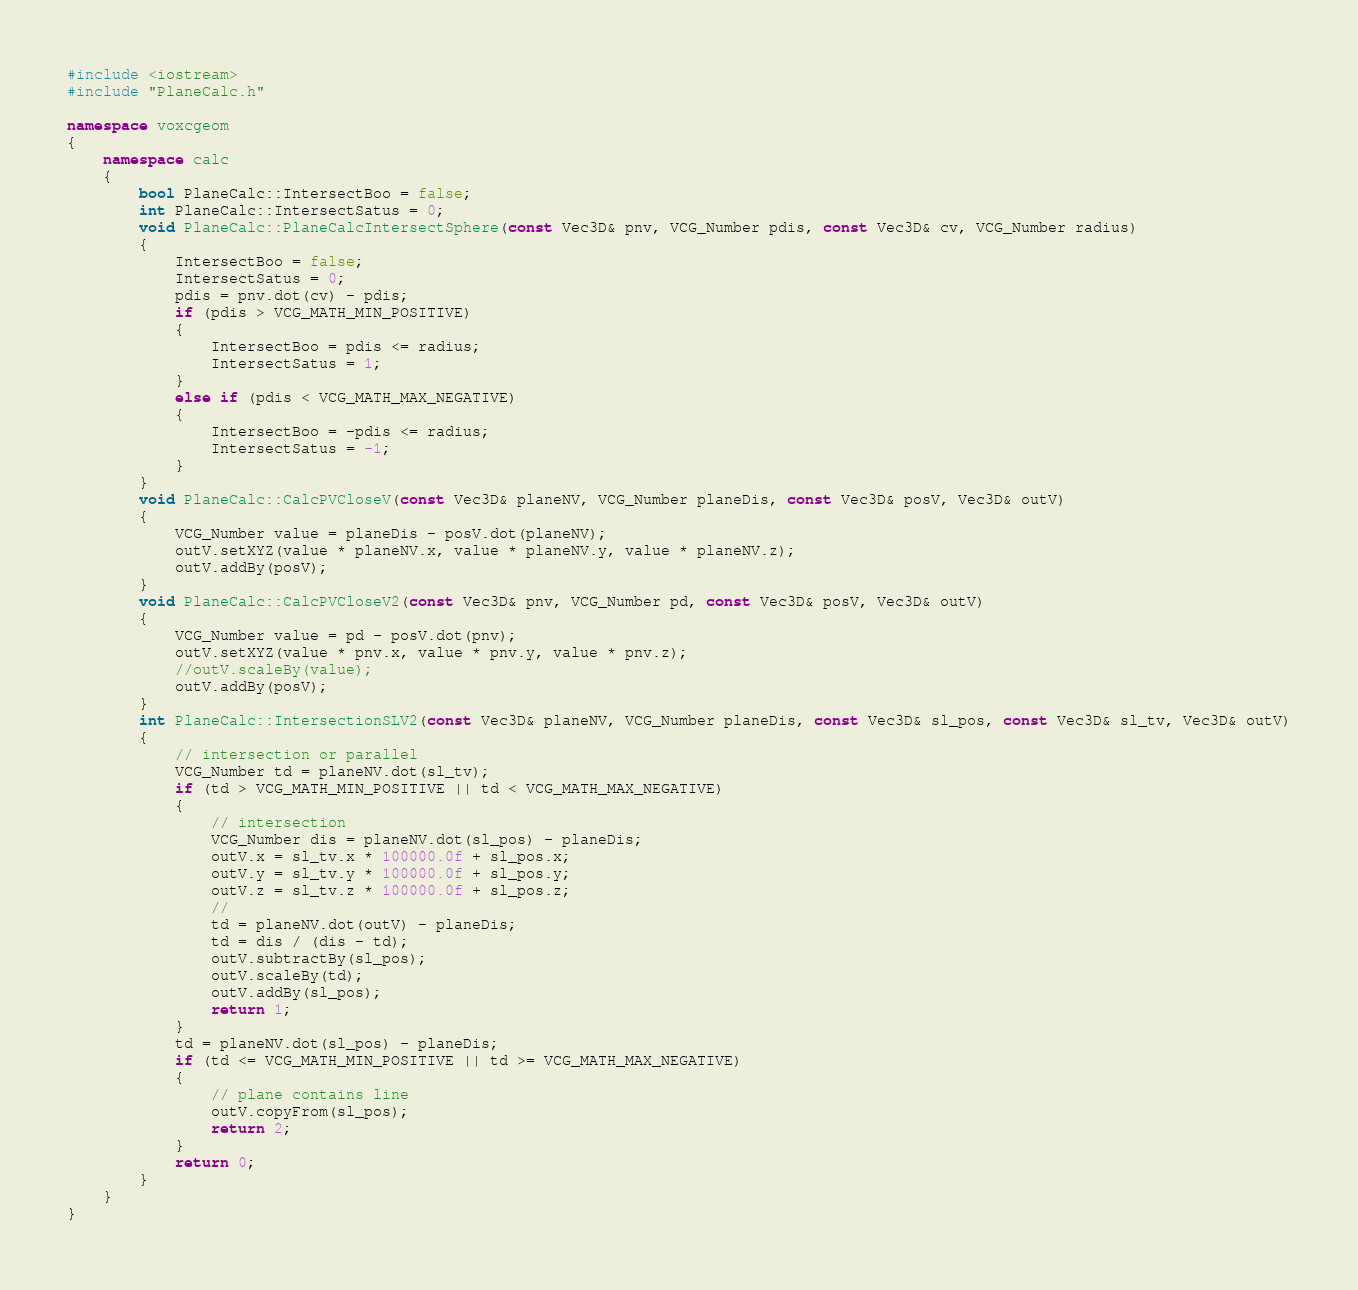Convert code to text. <code><loc_0><loc_0><loc_500><loc_500><_C++_>
#include <iostream>
#include "PlaneCalc.h"

namespace voxcgeom
{
	namespace calc
	{
		bool PlaneCalc::IntersectBoo = false;
		int PlaneCalc::IntersectSatus = 0;
		void PlaneCalc::PlaneCalcIntersectSphere(const Vec3D& pnv, VCG_Number pdis, const Vec3D& cv, VCG_Number radius)
		{
			IntersectBoo = false;
			IntersectSatus = 0;
			pdis = pnv.dot(cv) - pdis;
			if (pdis > VCG_MATH_MIN_POSITIVE)
			{
				IntersectBoo = pdis <= radius;
				IntersectSatus = 1;
			}
			else if (pdis < VCG_MATH_MAX_NEGATIVE)
			{
				IntersectBoo = -pdis <= radius;
				IntersectSatus = -1;
			}
		}
		void PlaneCalc::CalcPVCloseV(const Vec3D& planeNV, VCG_Number planeDis, const Vec3D& posV, Vec3D& outV)
		{
			VCG_Number value = planeDis - posV.dot(planeNV);
			outV.setXYZ(value * planeNV.x, value * planeNV.y, value * planeNV.z);
			outV.addBy(posV);
		}
		void PlaneCalc::CalcPVCloseV2(const Vec3D& pnv, VCG_Number pd, const Vec3D& posV, Vec3D& outV)
		{
			VCG_Number value = pd - posV.dot(pnv);
			outV.setXYZ(value * pnv.x, value * pnv.y, value * pnv.z);
			//outV.scaleBy(value);
			outV.addBy(posV);
		}
		int PlaneCalc::IntersectionSLV2(const Vec3D& planeNV, VCG_Number planeDis, const Vec3D& sl_pos, const Vec3D& sl_tv, Vec3D& outV)
		{
			// intersection or parallel
			VCG_Number td = planeNV.dot(sl_tv);
			if (td > VCG_MATH_MIN_POSITIVE || td < VCG_MATH_MAX_NEGATIVE)
			{
				// intersection
				VCG_Number dis = planeNV.dot(sl_pos) - planeDis;
				outV.x = sl_tv.x * 100000.0f + sl_pos.x;
				outV.y = sl_tv.y * 100000.0f + sl_pos.y;
				outV.z = sl_tv.z * 100000.0f + sl_pos.z;
				//
				td = planeNV.dot(outV) - planeDis;
				td = dis / (dis - td);
				outV.subtractBy(sl_pos);
				outV.scaleBy(td);
				outV.addBy(sl_pos);
				return 1;
			}
			td = planeNV.dot(sl_pos) - planeDis;
			if (td <= VCG_MATH_MIN_POSITIVE || td >= VCG_MATH_MAX_NEGATIVE)
			{
				// plane contains line
				outV.copyFrom(sl_pos);
				return 2;
			}
			return 0;
		}
	}
}</code> 